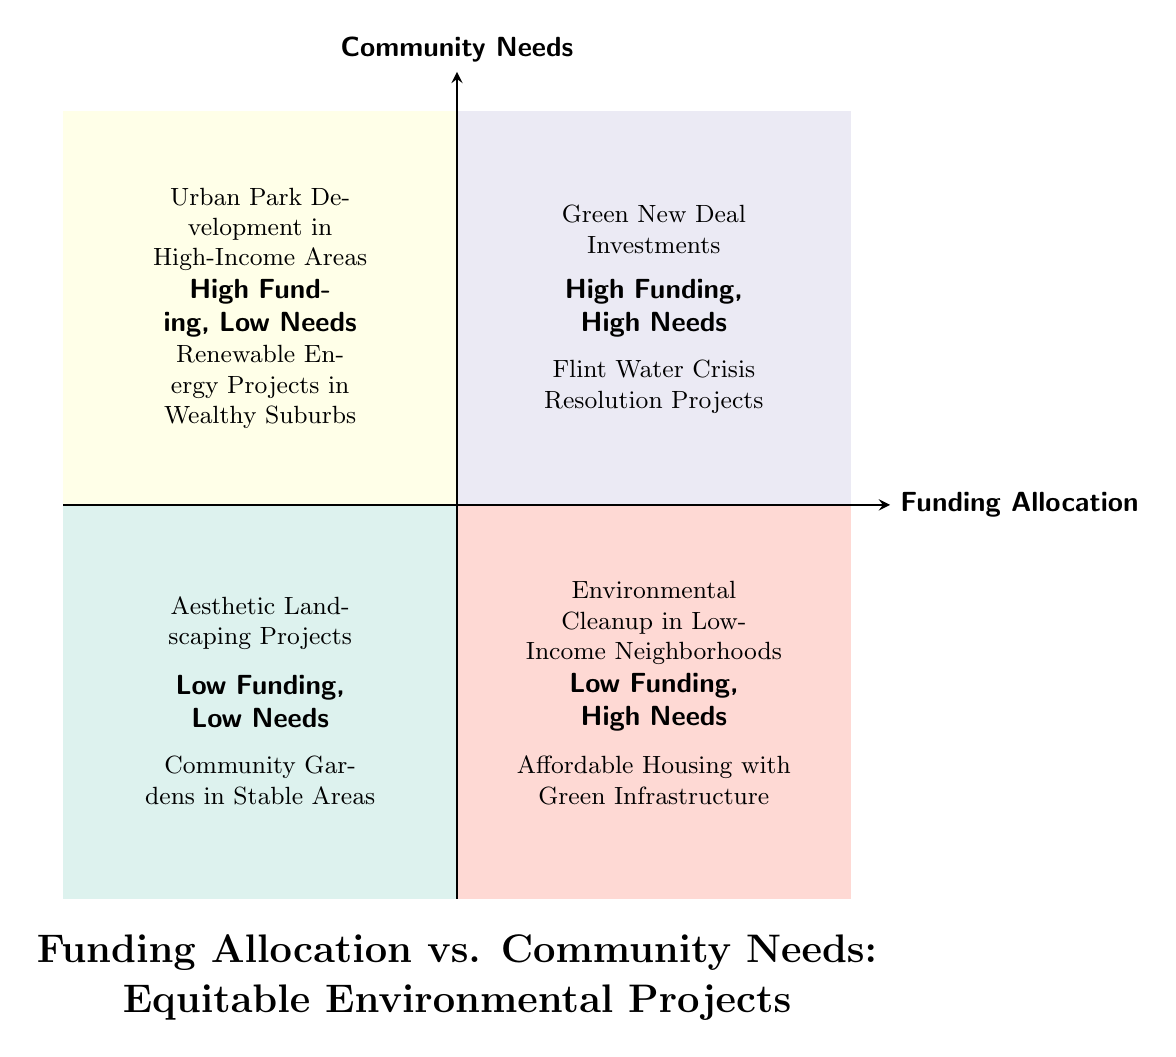What projects are located in the High Funding, High Needs quadrant? The projects listed in the High Funding, High Needs quadrant are directly specified in the diagram. They are "Green New Deal Investments" and "Flint Water Crisis Resolution Projects".
Answer: Green New Deal Investments, Flint Water Crisis Resolution Projects How many projects are in the Low Funding, Low Needs quadrant? There are two projects listed in the Low Funding, Low Needs quadrant. They are "Aesthetic Landscaping Projects" and "Community Gardens in Stable Areas".
Answer: 2 What funding allocation category does "Environmental Cleanup in Low-Income Neighborhoods" fall under? "Environmental Cleanup in Low-Income Neighborhoods" is shown in the Low Funding, High Needs quadrant, which indicates it needs significant community support despite low funding.
Answer: Low Funding, High Needs Which quadrant has projects focused on wealthy areas? The quadrant that includes projects focused on wealthy areas is the High Funding, Low Needs quadrant, where both "Urban Park Development in High-Income Areas" and "Renewable Energy Projects in Wealthy Suburbs" are located.
Answer: High Funding, Low Needs What is the relationship between the funding allocation and community needs in the Low Funding, High Needs quadrant? The Low Funding, High Needs quadrant highlights that, despite low funding levels, the community needs are significant and require attention, as demonstrated by projects like "Environmental Cleanup in Low-Income Neighborhoods".
Answer: High needs, low funding Which type of community needs are addressed by the projects in the High Funding, High Needs quadrant? The projects in the High Funding, High Needs quadrant are focused on addressing critical environmental issues, such as climate change and public health crises, indicating that they cater to pressing community needs.
Answer: Critical environmental issues What type of projects appear in the Low Funding, Low Needs quadrant? The Low Funding, Low Needs quadrant contains projects that are less impactful regarding community needs and funding, specifically "Aesthetic Landscaping Projects" and "Community Gardens in Stable Areas".
Answer: Aesthetic landscaping and community gardens Which projects represent the highest funding allocation? The projects that represent the highest funding allocation are found in the High Funding, High Needs quadrant, which includes "Green New Deal Investments" and "Flint Water Crisis Resolution Projects".
Answer: Green New Deal Investments, Flint Water Crisis Resolution Projects 